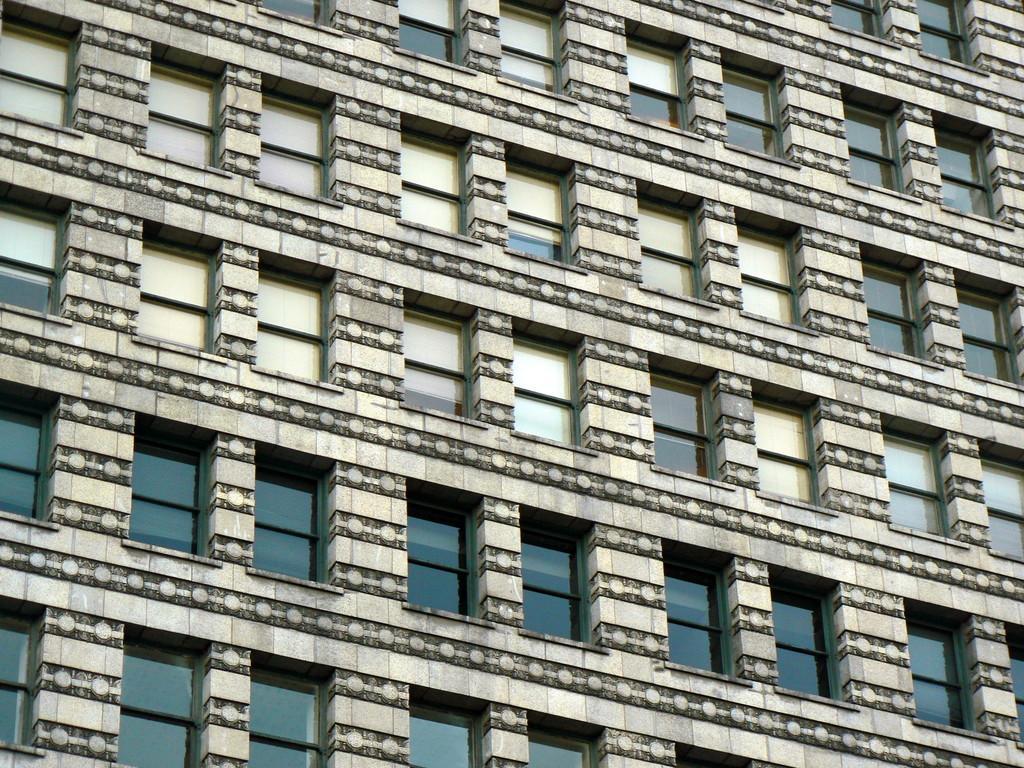Can you describe this image briefly? In this image we can see a building with windows. 